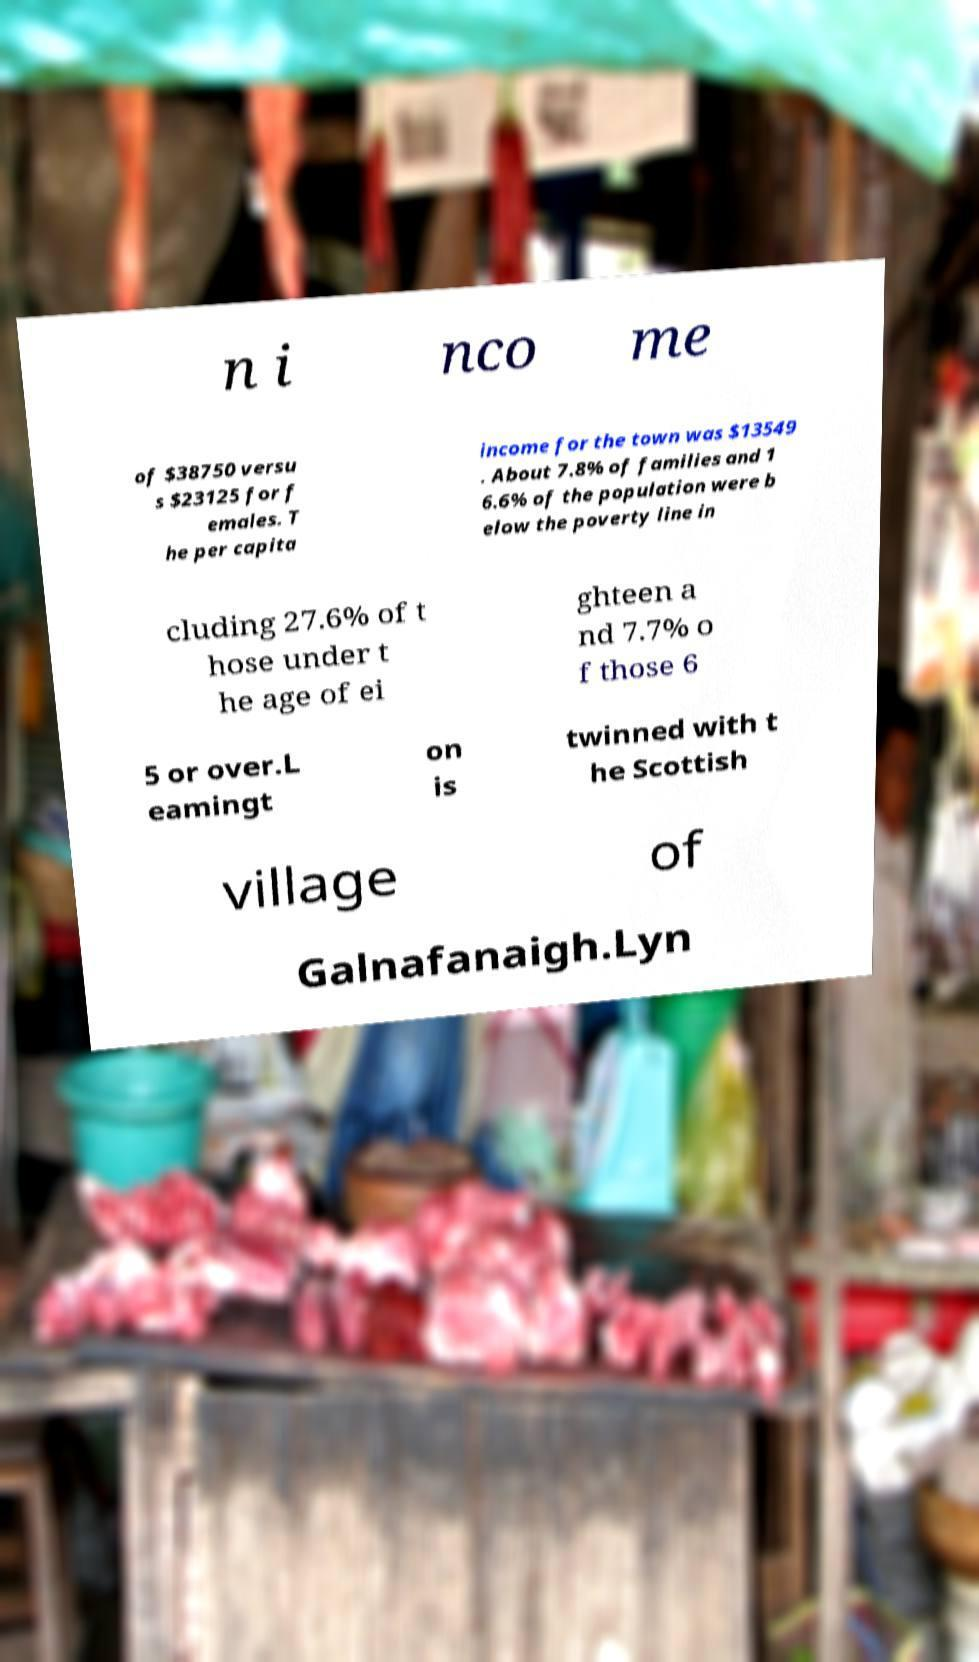Could you assist in decoding the text presented in this image and type it out clearly? n i nco me of $38750 versu s $23125 for f emales. T he per capita income for the town was $13549 . About 7.8% of families and 1 6.6% of the population were b elow the poverty line in cluding 27.6% of t hose under t he age of ei ghteen a nd 7.7% o f those 6 5 or over.L eamingt on is twinned with t he Scottish village of Galnafanaigh.Lyn 